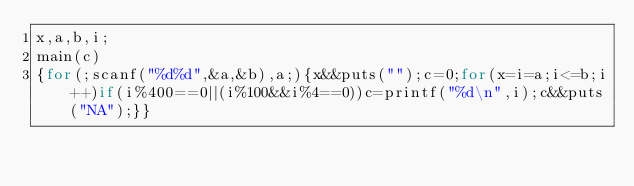Convert code to text. <code><loc_0><loc_0><loc_500><loc_500><_C_>x,a,b,i;
main(c)
{for(;scanf("%d%d",&a,&b),a;){x&&puts("");c=0;for(x=i=a;i<=b;i++)if(i%400==0||(i%100&&i%4==0))c=printf("%d\n",i);c&&puts("NA");}}</code> 